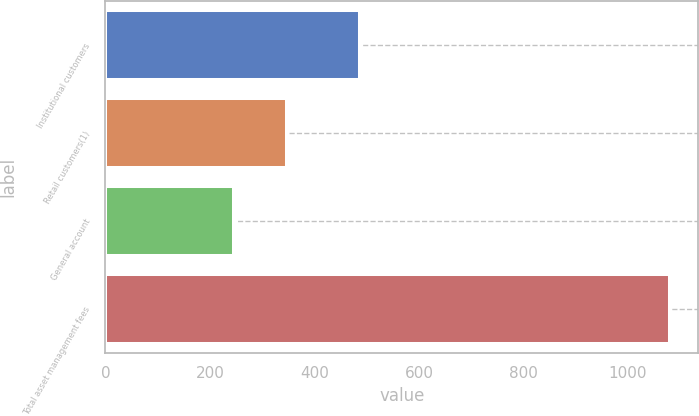<chart> <loc_0><loc_0><loc_500><loc_500><bar_chart><fcel>Institutional customers<fcel>Retail customers(1)<fcel>General account<fcel>Total asset management fees<nl><fcel>488<fcel>347<fcel>246<fcel>1081<nl></chart> 